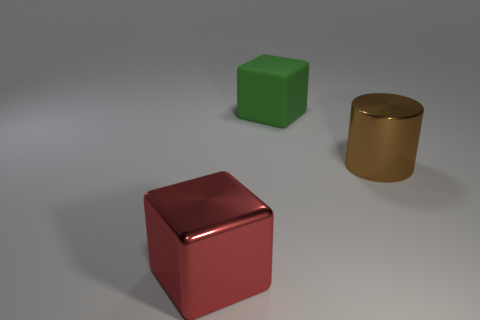Add 2 big metallic cubes. How many objects exist? 5 Subtract all cylinders. How many objects are left? 2 Add 2 big red metal objects. How many big red metal objects are left? 3 Add 3 metallic cylinders. How many metallic cylinders exist? 4 Subtract 0 yellow cylinders. How many objects are left? 3 Subtract all tiny yellow rubber cubes. Subtract all large blocks. How many objects are left? 1 